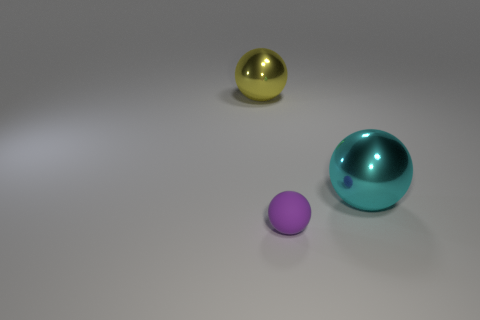Are the yellow object and the large ball on the right side of the big yellow object made of the same material?
Offer a very short reply. Yes. What number of other objects are the same shape as the purple matte object?
Offer a very short reply. 2. What number of things are spheres in front of the large cyan shiny object or metal balls that are to the left of the small matte object?
Offer a very short reply. 2. Is the number of big things that are right of the purple sphere less than the number of shiny spheres that are on the right side of the cyan shiny ball?
Ensure brevity in your answer.  No. How many cyan metal objects are there?
Your response must be concise. 1. Is there any other thing that is the same material as the purple ball?
Offer a very short reply. No. There is a big cyan object that is the same shape as the tiny matte thing; what is it made of?
Ensure brevity in your answer.  Metal. Is the number of metallic balls in front of the big cyan metal ball less than the number of tiny objects?
Give a very brief answer. Yes. Do the object that is in front of the big cyan ball and the big yellow object have the same shape?
Your answer should be compact. Yes. Is there anything else that is the same color as the tiny thing?
Provide a succinct answer. No. 